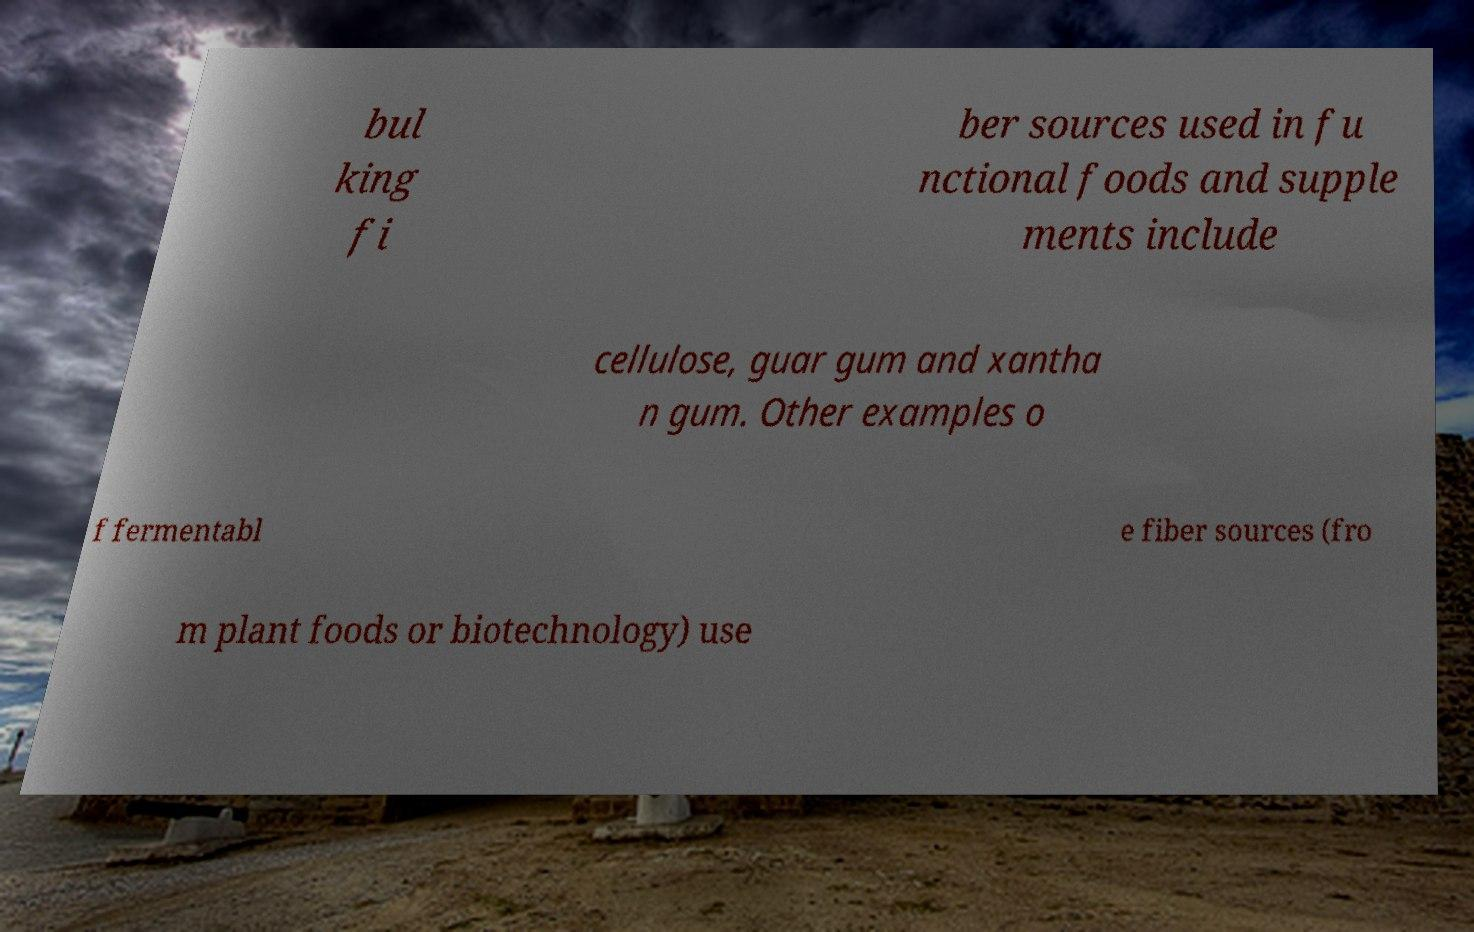What messages or text are displayed in this image? I need them in a readable, typed format. bul king fi ber sources used in fu nctional foods and supple ments include cellulose, guar gum and xantha n gum. Other examples o f fermentabl e fiber sources (fro m plant foods or biotechnology) use 